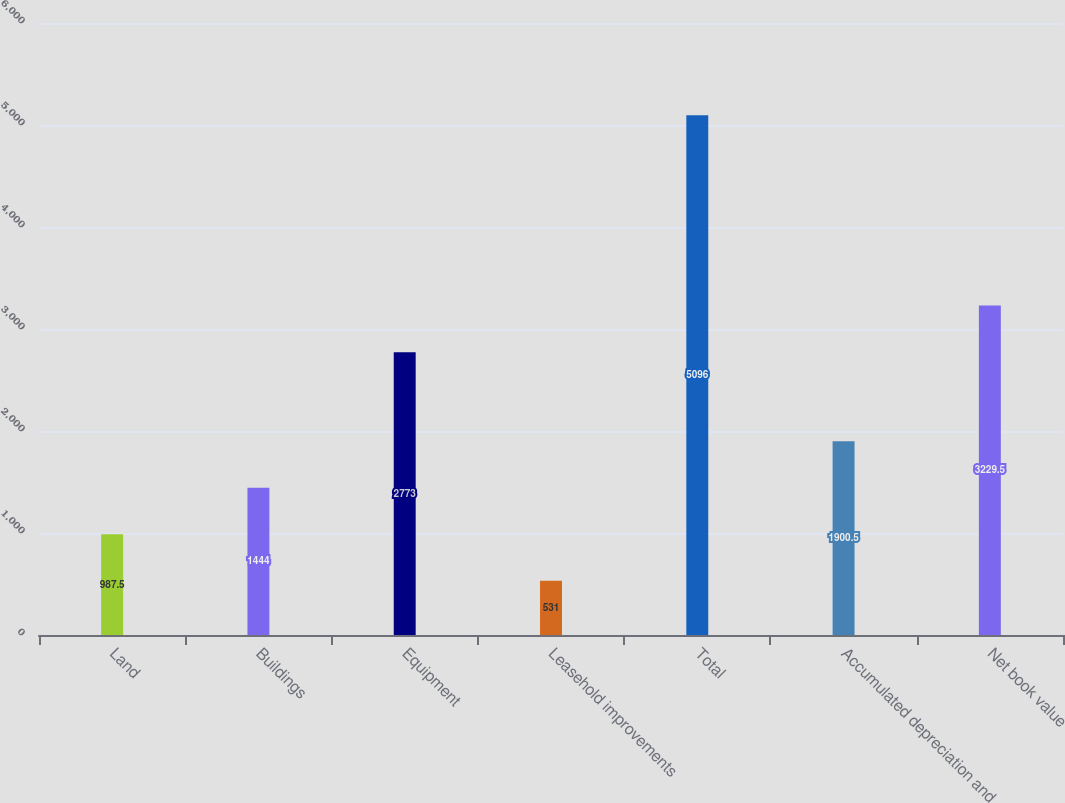Convert chart to OTSL. <chart><loc_0><loc_0><loc_500><loc_500><bar_chart><fcel>Land<fcel>Buildings<fcel>Equipment<fcel>Leasehold improvements<fcel>Total<fcel>Accumulated depreciation and<fcel>Net book value<nl><fcel>987.5<fcel>1444<fcel>2773<fcel>531<fcel>5096<fcel>1900.5<fcel>3229.5<nl></chart> 